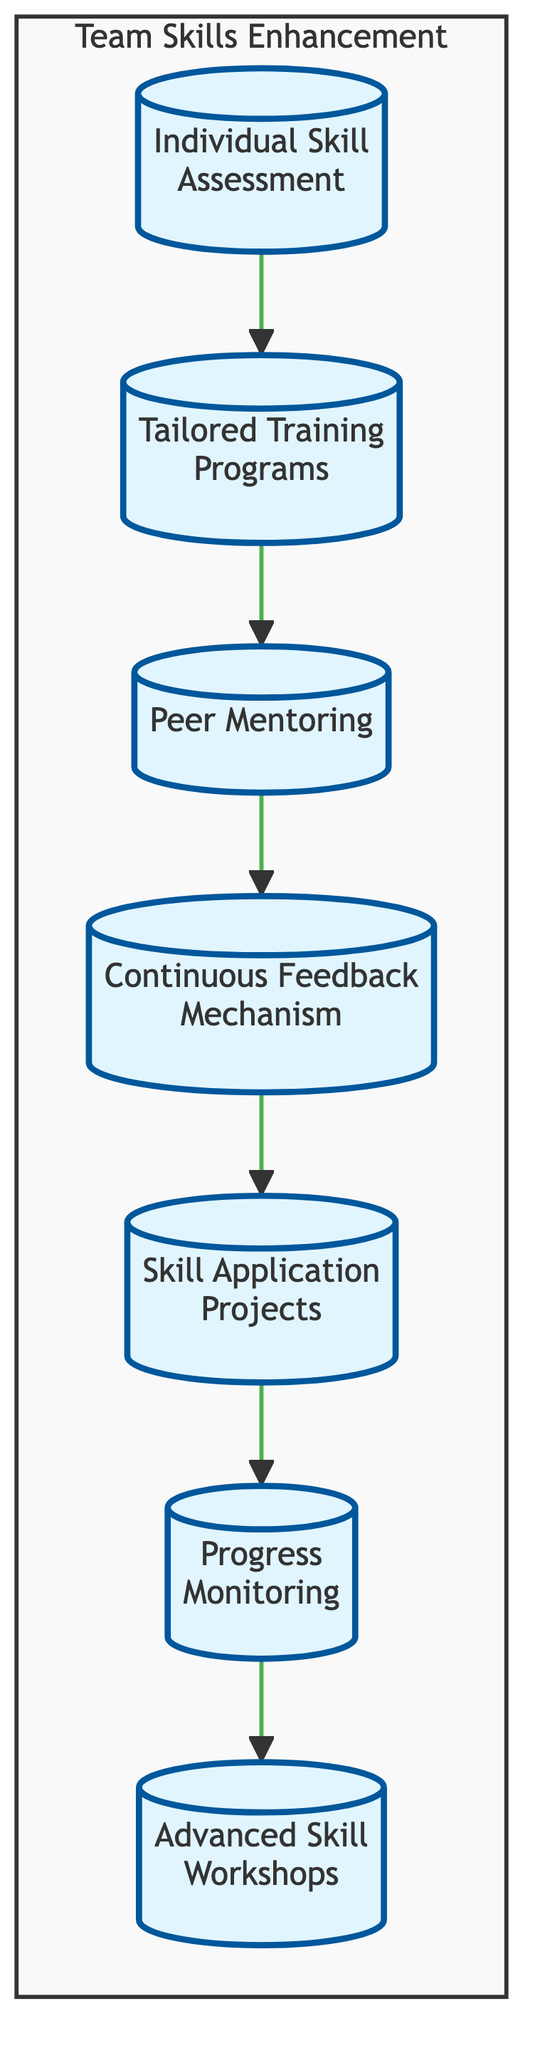What is the first step in the training pathway? The first step is "Individual Skill Assessment," which is the top node in the flowchart and indicates the initial action to assess team members' skills.
Answer: Individual Skill Assessment How many elements are there in the training pathway? The flowchart includes a total of seven elements, as counted from the nodes listed in the diagram.
Answer: 7 What follows the "Tailored Training Programs"? After "Tailored Training Programs," the next step in the flowchart is "Peer Mentoring," indicating that mentoring follows the training development.
Answer: Peer Mentoring Which element is connected to both "Skill Application Projects" and "Progress Monitoring"? "Skill Application Projects" leads to "Progress Monitoring," indicating that after applying skills, the progress is monitored.
Answer: Progress Monitoring What does the "Continuous Feedback Mechanism" facilitate? The "Continuous Feedback Mechanism" facilitates ongoing development by providing regular feedback sessions to team members.
Answer: Ongoing development Which element is the last in the pathway? The last element in the training pathway is "Advanced Skill Workshops," which concludes the sequence of training activities.
Answer: Advanced Skill Workshops What is the main purpose of the "Peer Mentoring" step? The main purpose of "Peer Mentoring" is to establish a system where experienced team members guide less experienced colleagues to enhance team skills.
Answer: Guide less experienced colleagues Which two elements are directly connected to "Individual Skill Assessment"? "Individual Skill Assessment" is directly connected to "Tailored Training Programs" and does not have any other direct connections.
Answer: Tailored Training Programs What type of projects are included in the pathway? The pathway includes "Skill Application Projects," which are designed to allow team members to apply their newly learned skills in practical situations.
Answer: Skill Application Projects 